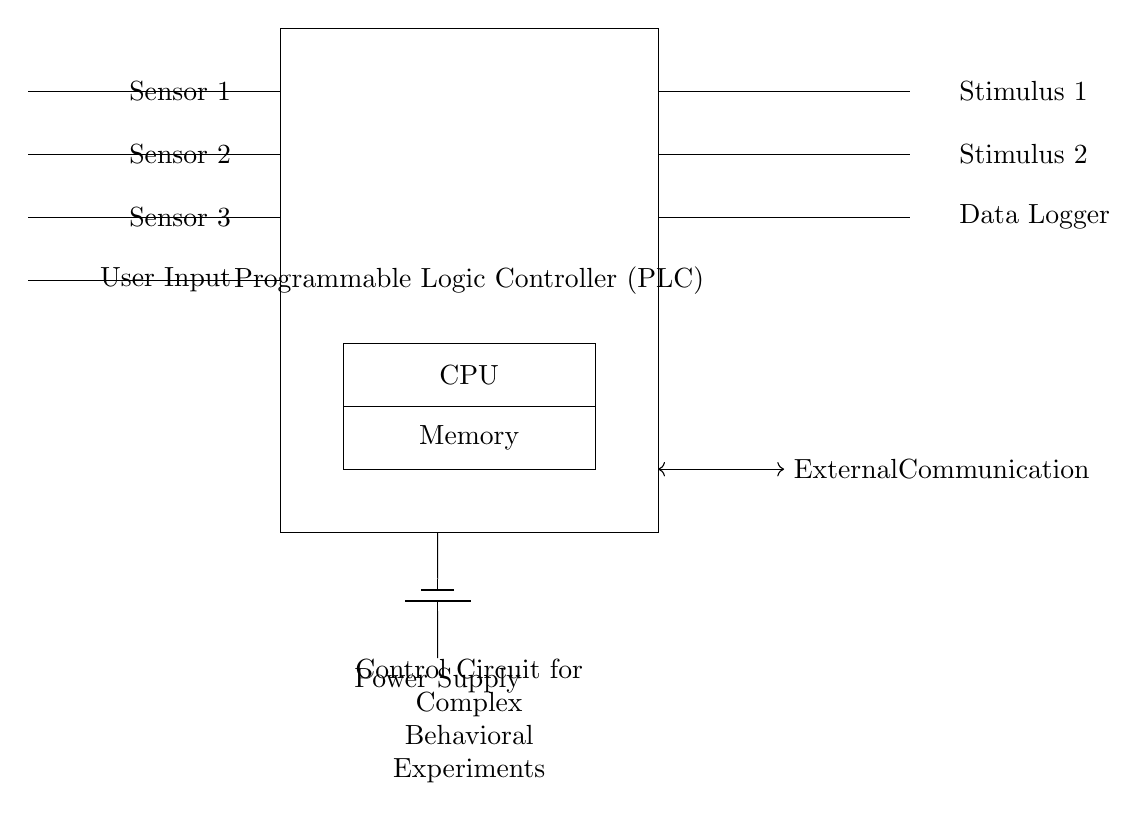What are the input components of the circuit? The input components, as shown in the circuit diagram, are Sensor 1, Sensor 2, Sensor 3, and User Input, which are positioned on the left side of the programmable logic controller.
Answer: Sensor 1, Sensor 2, Sensor 3, User Input What is the output from the Programmable Logic Controller? The outputs indicated in the circuit are Stimulus 1, Stimulus 2, and Data Logger, which are connected to the right side of the PLC.
Answer: Stimulus 1, Stimulus 2, Data Logger Which component manages data processing in the circuit? The CPU is the component within the circuit responsible for managing data processing, as illustrated by its placement in the center of the PLC rectangle in the diagram.
Answer: CPU What is the purpose of the memory component? The Memory component stores information and configurations needed for the PLC to perform its tasks, as represented directly below the CPU in the circuit diagram.
Answer: Storage How does external communication occur according to the diagram? External communication is facilitated through a two-way connection represented by the double-headed arrow between the PLC output side and an external point, indicating bidirectional data flow.
Answer: Bidirectional communication Why might a power supply be critical in this circuit? A power supply is essential as it provides the necessary electrical energy for the entire circuit and its components to operate, indicated by the battery symbol at the bottom of the diagram.
Answer: Energy source What is the significance of using a programmable logic controller in this setup? A programmable logic controller enables the automation and control of various input and output signals, allowing for effective management of complex behavioral experiments, as presented by its central placement and functionality in the diagram.
Answer: Automation and control 